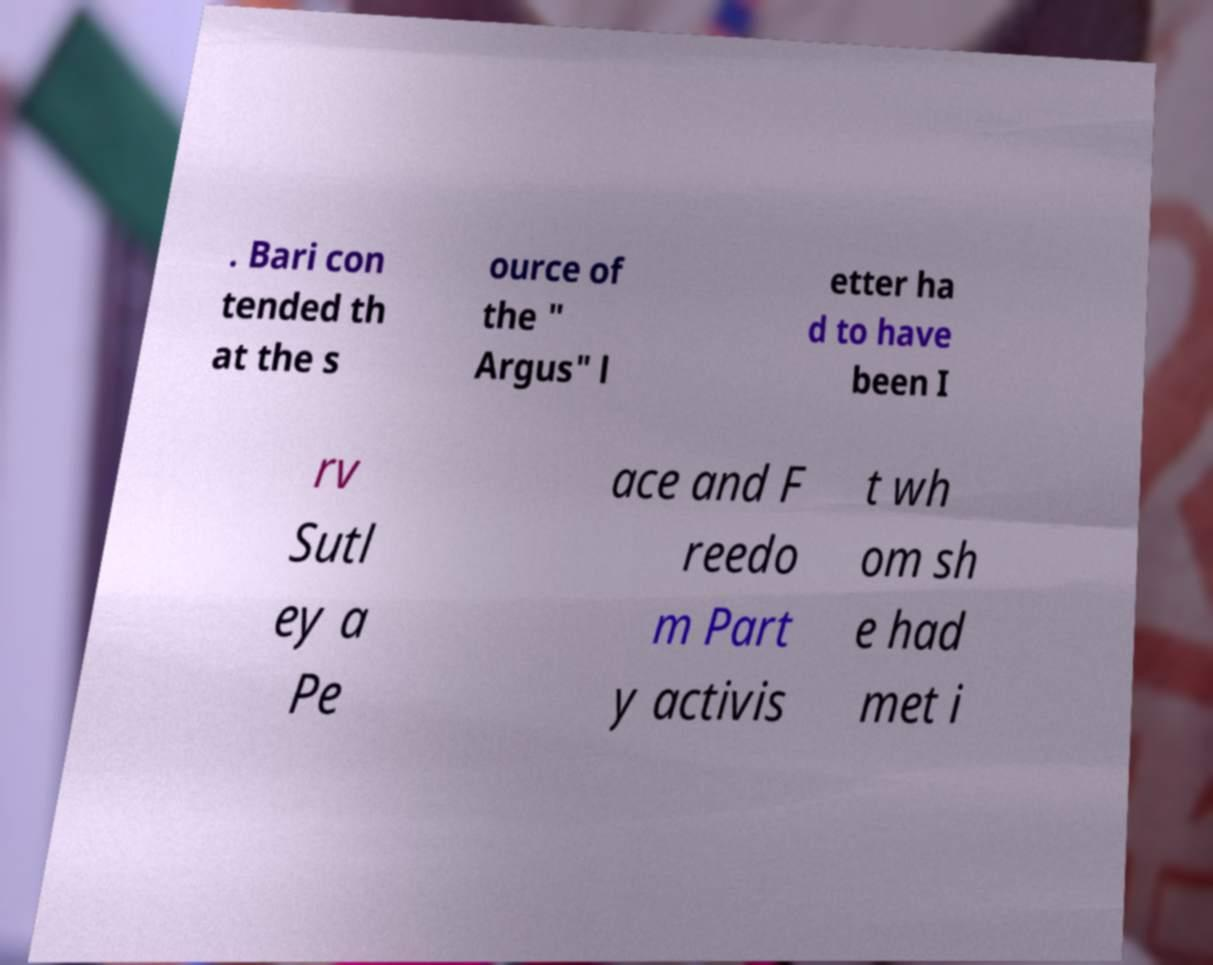I need the written content from this picture converted into text. Can you do that? . Bari con tended th at the s ource of the " Argus" l etter ha d to have been I rv Sutl ey a Pe ace and F reedo m Part y activis t wh om sh e had met i 